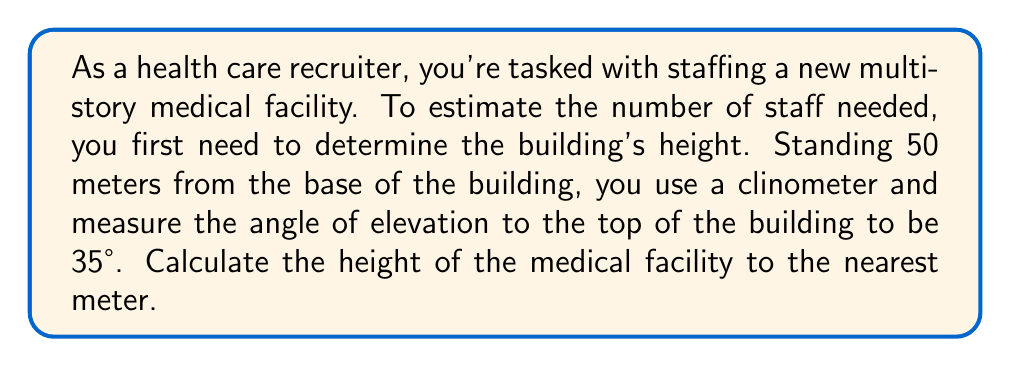What is the answer to this math problem? Let's approach this step-by-step using trigonometric ratios:

1) First, let's visualize the problem:

[asy]
import geometry;

size(200);

pair A = (0,0), B = (5,0), C = (5,3.5);
draw(A--B--C--A);

label("50m", (2.5,0), S);
label("h", (5,1.75), E);
label("35°", (0.5,0.3), NE);

draw(A--(1,0), arrow=Arrow(TeXHead));
draw((1,0)--(1,0.7), arrow=Arrow(TeXHead));

dot("A", A, SW);
dot("B", B, SE);
dot("C", C, NE);
[/asy]

2) In this right-angled triangle:
   - The adjacent side is the distance from you to the building (50 meters)
   - The opposite side is the height of the building (h)
   - The angle of elevation is 35°

3) We need to find the opposite side. The trigonometric ratio that relates the opposite side to the adjacent side is the tangent:

   $$\tan \theta = \frac{\text{opposite}}{\text{adjacent}}$$

4) Substituting our known values:

   $$\tan 35° = \frac{h}{50}$$

5) To solve for h, multiply both sides by 50:

   $$h = 50 \tan 35°$$

6) Using a calculator (or trigonometric tables):

   $$h = 50 \times 0.7002 = 35.01$$

7) Rounding to the nearest meter:

   $$h \approx 35 \text{ meters}$$
Answer: The height of the medical facility is approximately 35 meters. 